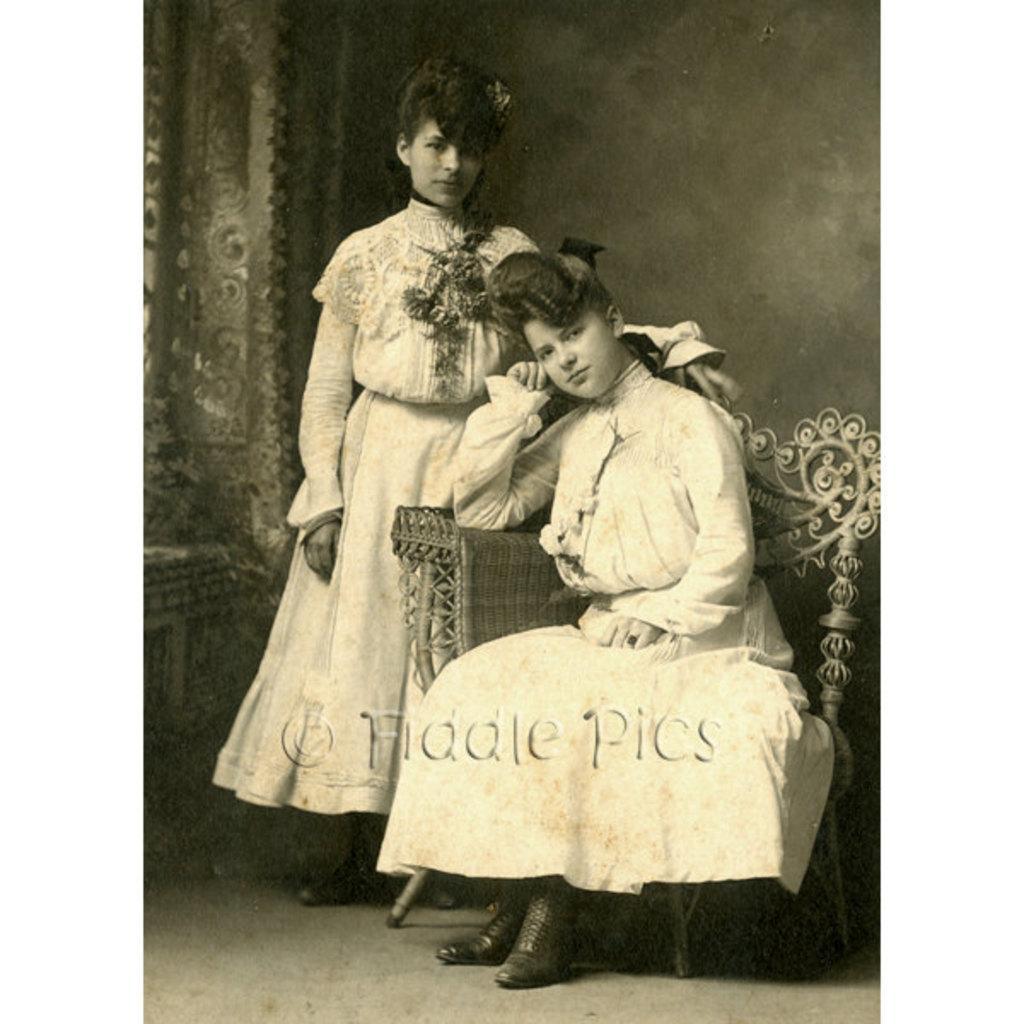How would you summarize this image in a sentence or two? In this image I can see two girls and I can see both of them are wearing same kind of dress. I can also see one is sitting on a chair and one is standing. On the bottom side of the image I can see a watermark. 